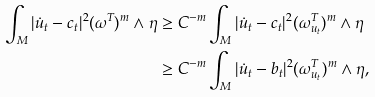Convert formula to latex. <formula><loc_0><loc_0><loc_500><loc_500>\int _ { M } | \dot { u } _ { t } - c _ { t } | ^ { 2 } ( \omega ^ { T } ) ^ { m } \wedge \eta & \geq C ^ { - m } \int _ { M } | \dot { u } _ { t } - c _ { t } | ^ { 2 } ( \omega ^ { T } _ { u _ { t } } ) ^ { m } \wedge \eta \\ & \geq C ^ { - m } \int _ { M } | \dot { u } _ { t } - b _ { t } | ^ { 2 } ( \omega ^ { T } _ { u _ { t } } ) ^ { m } \wedge \eta ,</formula> 